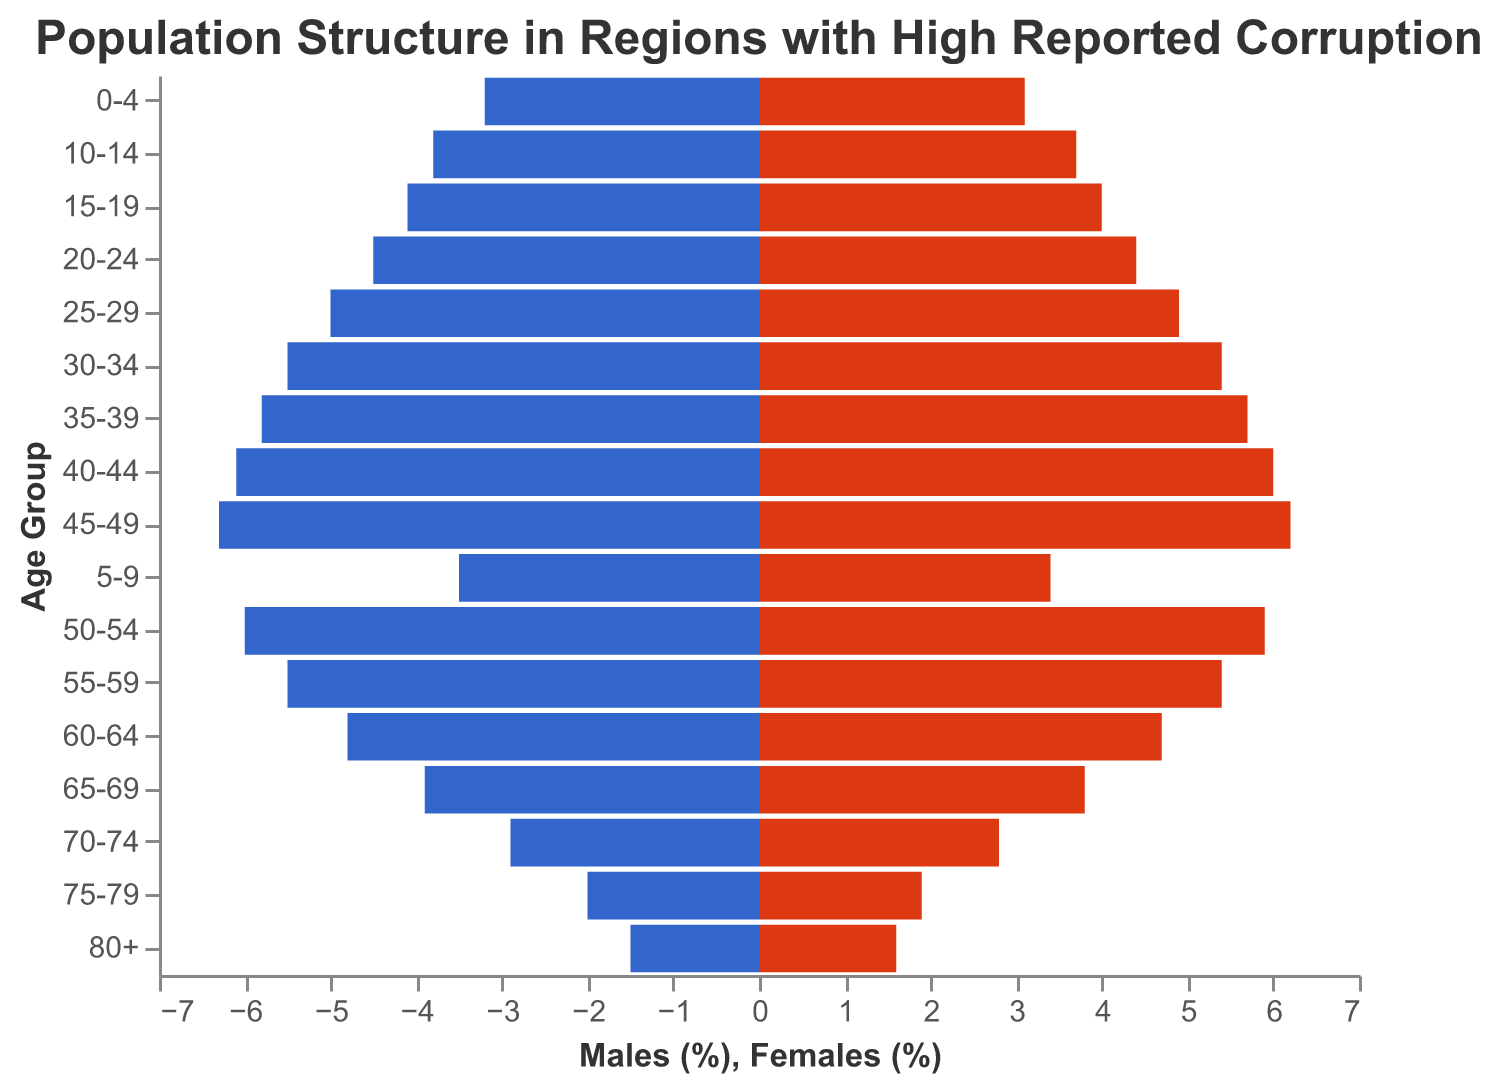What is the highest percentage of any age group for males? The highest percentage of males in any age group is 6.3% in the 45-49 age group. This can be seen in the bar chart where the length of the bar for males in the 45-49 age group is the longest.
Answer: 6.3% What is the title of the figure? The title of the figure is displayed at the top and reads "Population Structure in Regions with High Reported Corruption".
Answer: Population Structure in Regions with High Reported Corruption Which age group shows a higher percentage of females compared to males? By comparing the lengths of the bars for males and females across age groups, the 80+ age group shows a higher percentage for females (1.6%) than males (1.5%).
Answer: 80+ In which age group is the percentage of the population nearly equal for both males and females? The 0-4 age group shows nearly equal percentages for both males (3.2%) and females (3.1%), as the lengths of the bars are very close in size.
Answer: 0-4 What is the percentage difference between males and females in the 50-54 age group? The percentage for males in the 50-54 age group is 6.0%, and for females, it is 5.9%. The difference is 6.0% - 5.9% = 0.1%.
Answer: 0.1% Which age group has the smallest percentage of the population overall? Both males and females have the smallest percentages in the 80+ age group with 1.5% and 1.6%, respectively. This is evident from the shortest bars in the chart.
Answer: 80+ How does the percentage of males in the 25-29 age group compare to the 55-59 age group? The percentage of males in the 25-29 age group is 5.0%, while in the 55-59 age group, it is 5.5%. Therefore, the percentage of males is higher in the 55-59 age group compared to the 25-29 age group.
Answer: 55-59 has more What is the overall trend in population percentage from the younger age groups to older age groups? The overall trend shows that the population percentage is highest in middle-aged groups (35-49) and tends to decrease as age increases toward the older age groups (70+). This is observable as the bars gradually decrease in length from the middle age groups to the older age groups.
Answer: Decreasing trend Which age group has the highest discrepancy between males and females? The age group 35-39 has a discrepancy of 0.1% between males (5.8%) and females (5.7%). By noticing the slight differences in bar lengths, we can observe this minor discrepancy.
Answer: 35-39 